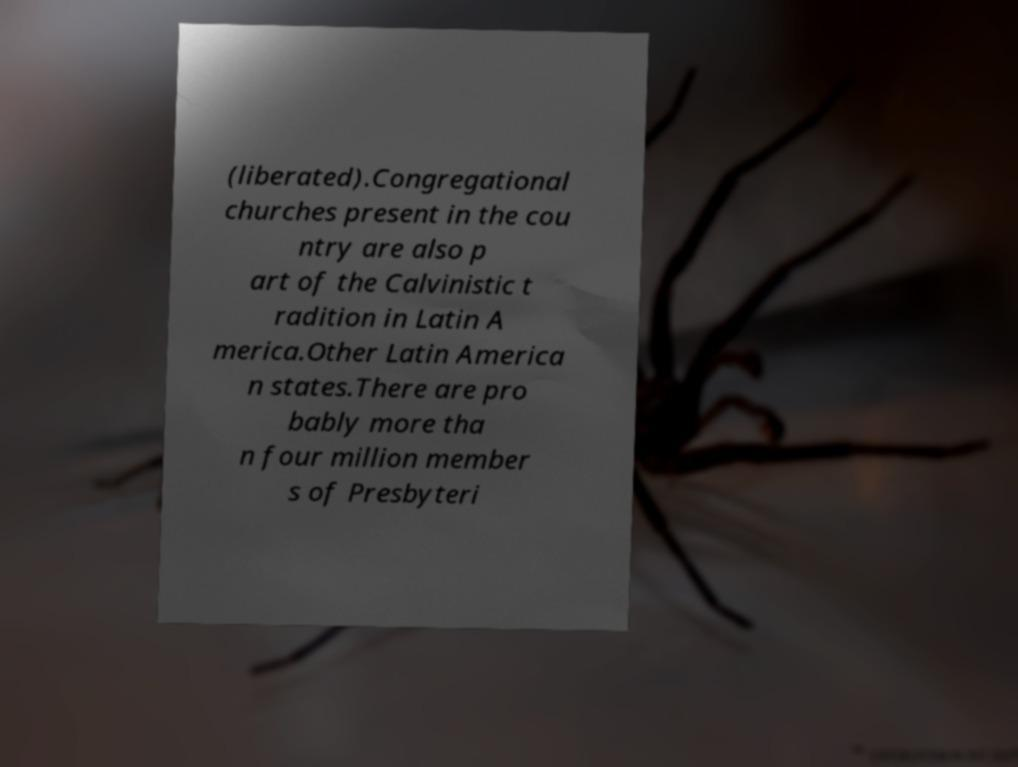Could you extract and type out the text from this image? (liberated).Congregational churches present in the cou ntry are also p art of the Calvinistic t radition in Latin A merica.Other Latin America n states.There are pro bably more tha n four million member s of Presbyteri 